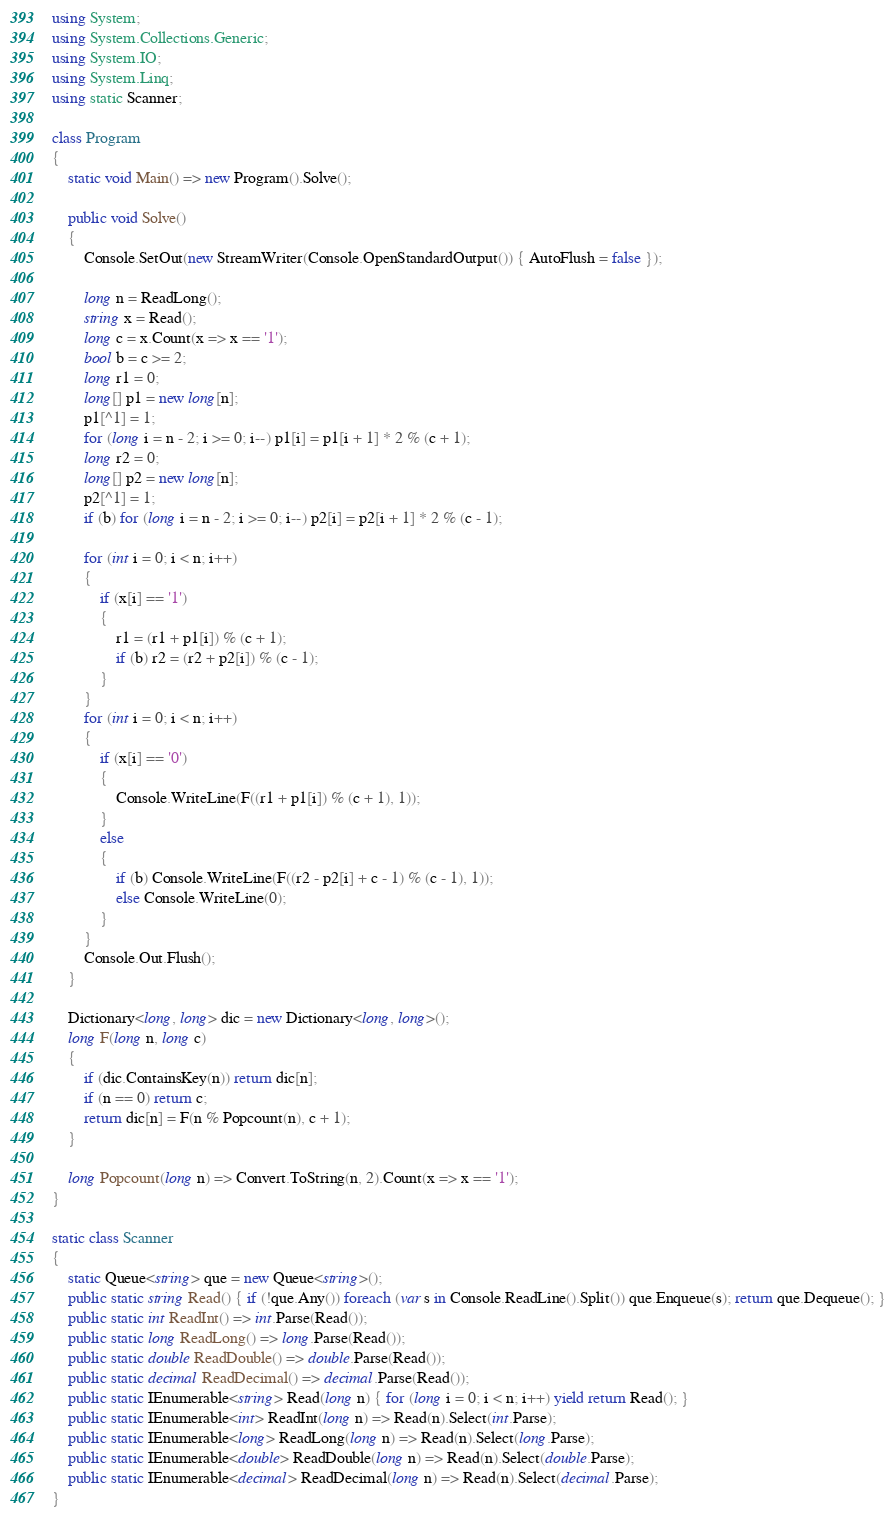<code> <loc_0><loc_0><loc_500><loc_500><_C#_>using System;
using System.Collections.Generic;
using System.IO;
using System.Linq;
using static Scanner;

class Program
{
    static void Main() => new Program().Solve();

    public void Solve()
    {
        Console.SetOut(new StreamWriter(Console.OpenStandardOutput()) { AutoFlush = false });

        long n = ReadLong();
        string x = Read();
        long c = x.Count(x => x == '1');
        bool b = c >= 2;
        long r1 = 0;
        long[] p1 = new long[n];
        p1[^1] = 1;
        for (long i = n - 2; i >= 0; i--) p1[i] = p1[i + 1] * 2 % (c + 1);
        long r2 = 0;
        long[] p2 = new long[n];
        p2[^1] = 1;
        if (b) for (long i = n - 2; i >= 0; i--) p2[i] = p2[i + 1] * 2 % (c - 1);

        for (int i = 0; i < n; i++)
        {
            if (x[i] == '1')
            {
                r1 = (r1 + p1[i]) % (c + 1);
                if (b) r2 = (r2 + p2[i]) % (c - 1);
            }
        }
        for (int i = 0; i < n; i++)
        {
            if (x[i] == '0')
            {
                Console.WriteLine(F((r1 + p1[i]) % (c + 1), 1));
            }
            else
            {
                if (b) Console.WriteLine(F((r2 - p2[i] + c - 1) % (c - 1), 1));
                else Console.WriteLine(0);
            }
        }
        Console.Out.Flush();
    }

    Dictionary<long, long> dic = new Dictionary<long, long>();
    long F(long n, long c)
    {
        if (dic.ContainsKey(n)) return dic[n];
        if (n == 0) return c;
        return dic[n] = F(n % Popcount(n), c + 1);
    }

    long Popcount(long n) => Convert.ToString(n, 2).Count(x => x == '1');
}

static class Scanner
{
    static Queue<string> que = new Queue<string>();
    public static string Read() { if (!que.Any()) foreach (var s in Console.ReadLine().Split()) que.Enqueue(s); return que.Dequeue(); }
    public static int ReadInt() => int.Parse(Read());
    public static long ReadLong() => long.Parse(Read());
    public static double ReadDouble() => double.Parse(Read());
    public static decimal ReadDecimal() => decimal.Parse(Read());
    public static IEnumerable<string> Read(long n) { for (long i = 0; i < n; i++) yield return Read(); }
    public static IEnumerable<int> ReadInt(long n) => Read(n).Select(int.Parse);
    public static IEnumerable<long> ReadLong(long n) => Read(n).Select(long.Parse);
    public static IEnumerable<double> ReadDouble(long n) => Read(n).Select(double.Parse);
    public static IEnumerable<decimal> ReadDecimal(long n) => Read(n).Select(decimal.Parse);
}
</code> 